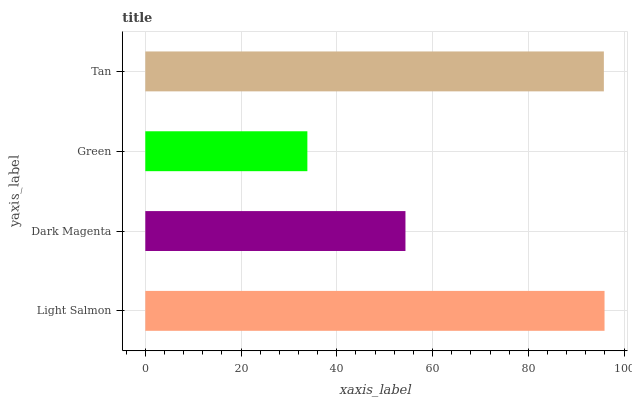Is Green the minimum?
Answer yes or no. Yes. Is Light Salmon the maximum?
Answer yes or no. Yes. Is Dark Magenta the minimum?
Answer yes or no. No. Is Dark Magenta the maximum?
Answer yes or no. No. Is Light Salmon greater than Dark Magenta?
Answer yes or no. Yes. Is Dark Magenta less than Light Salmon?
Answer yes or no. Yes. Is Dark Magenta greater than Light Salmon?
Answer yes or no. No. Is Light Salmon less than Dark Magenta?
Answer yes or no. No. Is Tan the high median?
Answer yes or no. Yes. Is Dark Magenta the low median?
Answer yes or no. Yes. Is Light Salmon the high median?
Answer yes or no. No. Is Tan the low median?
Answer yes or no. No. 